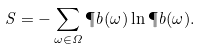Convert formula to latex. <formula><loc_0><loc_0><loc_500><loc_500>S = - \sum _ { \omega \in \Omega } \P b ( \omega ) \ln \P b ( \omega ) .</formula> 